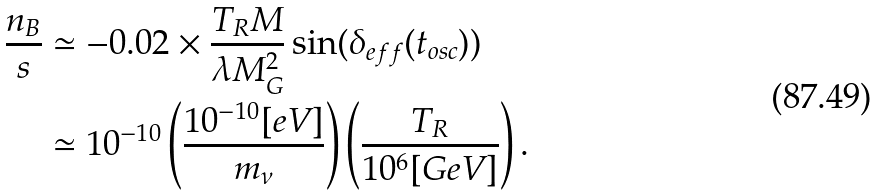<formula> <loc_0><loc_0><loc_500><loc_500>\frac { n _ { B } } { s } & \simeq - 0 . 0 2 \times \frac { T _ { R } M } { \lambda M _ { G } ^ { 2 } } \sin ( \delta _ { e f f } ( t _ { o s c } ) ) \\ & \simeq 1 0 ^ { - 1 0 } \left ( \frac { 1 0 ^ { - 1 0 } [ e V ] } { m _ { \nu } } \right ) \left ( \frac { T _ { R } } { 1 0 ^ { 6 } [ G e V ] } \right ) .</formula> 